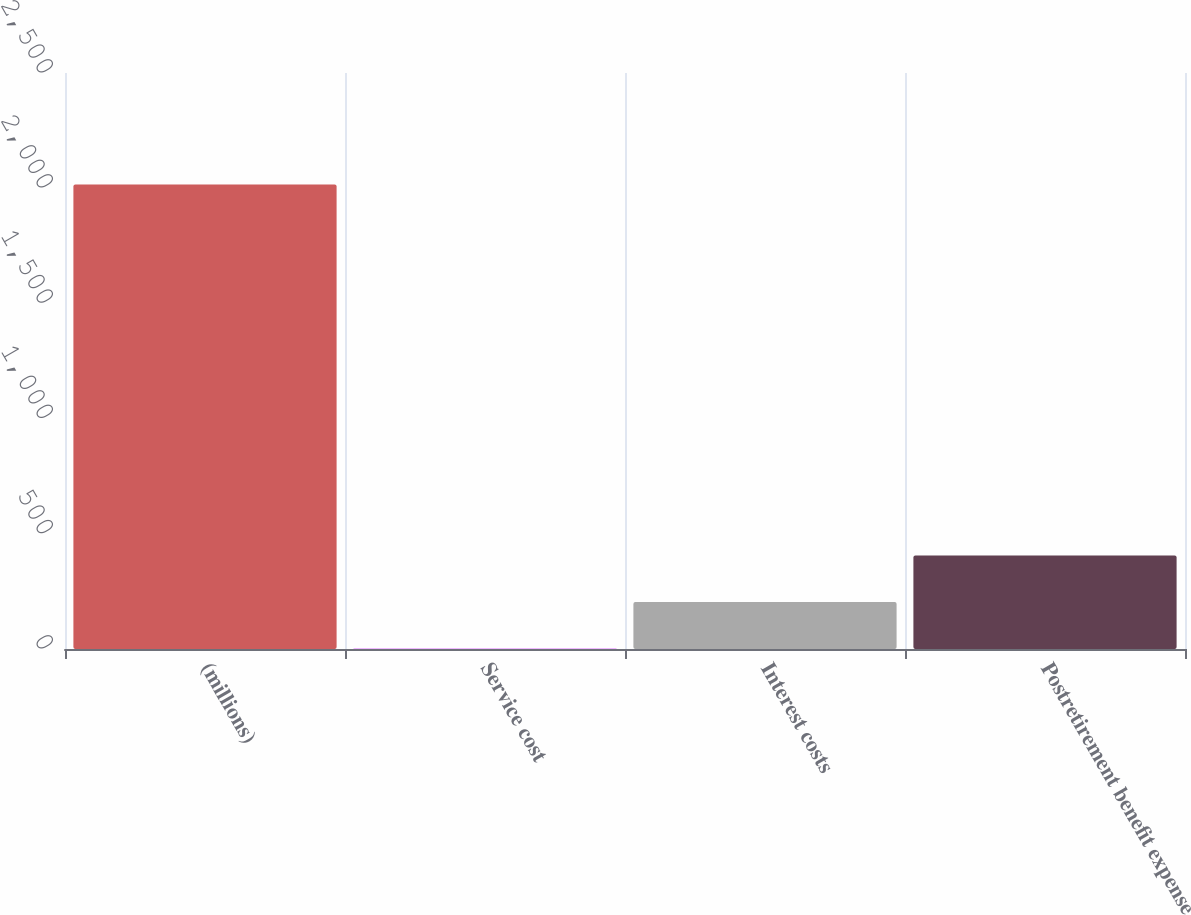Convert chart. <chart><loc_0><loc_0><loc_500><loc_500><bar_chart><fcel>(millions)<fcel>Service cost<fcel>Interest costs<fcel>Postretirement benefit expense<nl><fcel>2016<fcel>2.7<fcel>204.03<fcel>405.36<nl></chart> 